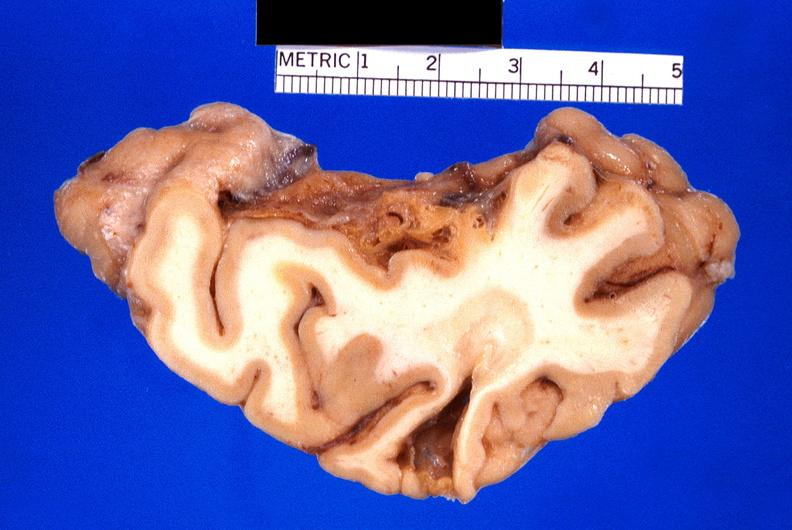what is present?
Answer the question using a single word or phrase. Nervous 